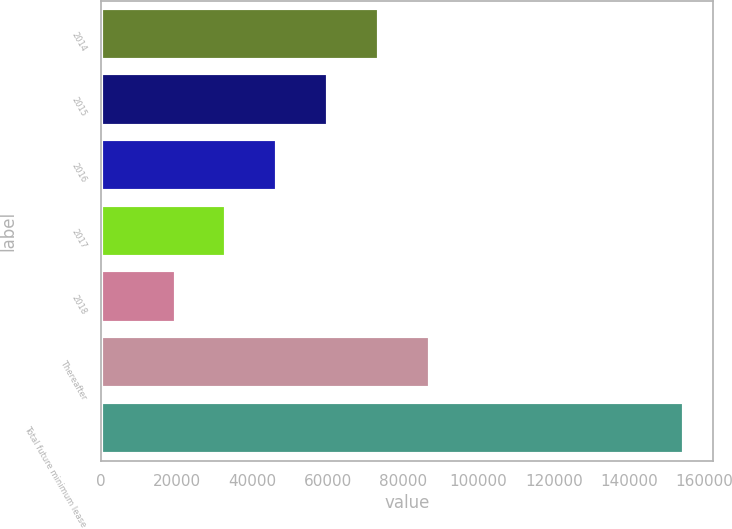Convert chart to OTSL. <chart><loc_0><loc_0><loc_500><loc_500><bar_chart><fcel>2014<fcel>2015<fcel>2016<fcel>2017<fcel>2018<fcel>Thereafter<fcel>Total future minimum lease<nl><fcel>73645.4<fcel>60152.8<fcel>46660.2<fcel>33167.6<fcel>19675<fcel>87138<fcel>154601<nl></chart> 